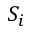<formula> <loc_0><loc_0><loc_500><loc_500>S _ { i }</formula> 